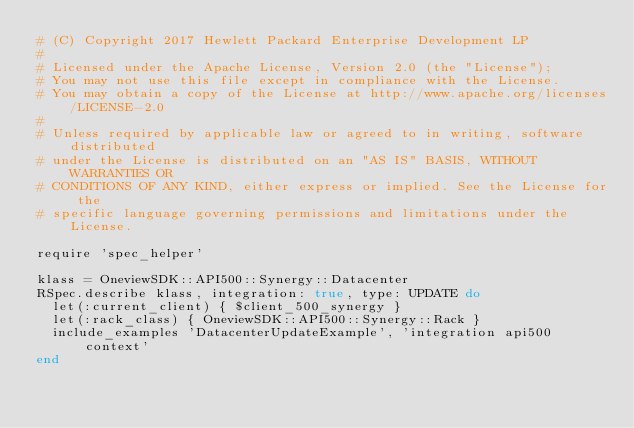<code> <loc_0><loc_0><loc_500><loc_500><_Ruby_># (C) Copyright 2017 Hewlett Packard Enterprise Development LP
#
# Licensed under the Apache License, Version 2.0 (the "License");
# You may not use this file except in compliance with the License.
# You may obtain a copy of the License at http://www.apache.org/licenses/LICENSE-2.0
#
# Unless required by applicable law or agreed to in writing, software distributed
# under the License is distributed on an "AS IS" BASIS, WITHOUT WARRANTIES OR
# CONDITIONS OF ANY KIND, either express or implied. See the License for the
# specific language governing permissions and limitations under the License.

require 'spec_helper'

klass = OneviewSDK::API500::Synergy::Datacenter
RSpec.describe klass, integration: true, type: UPDATE do
  let(:current_client) { $client_500_synergy }
  let(:rack_class) { OneviewSDK::API500::Synergy::Rack }
  include_examples 'DatacenterUpdateExample', 'integration api500 context'
end
</code> 